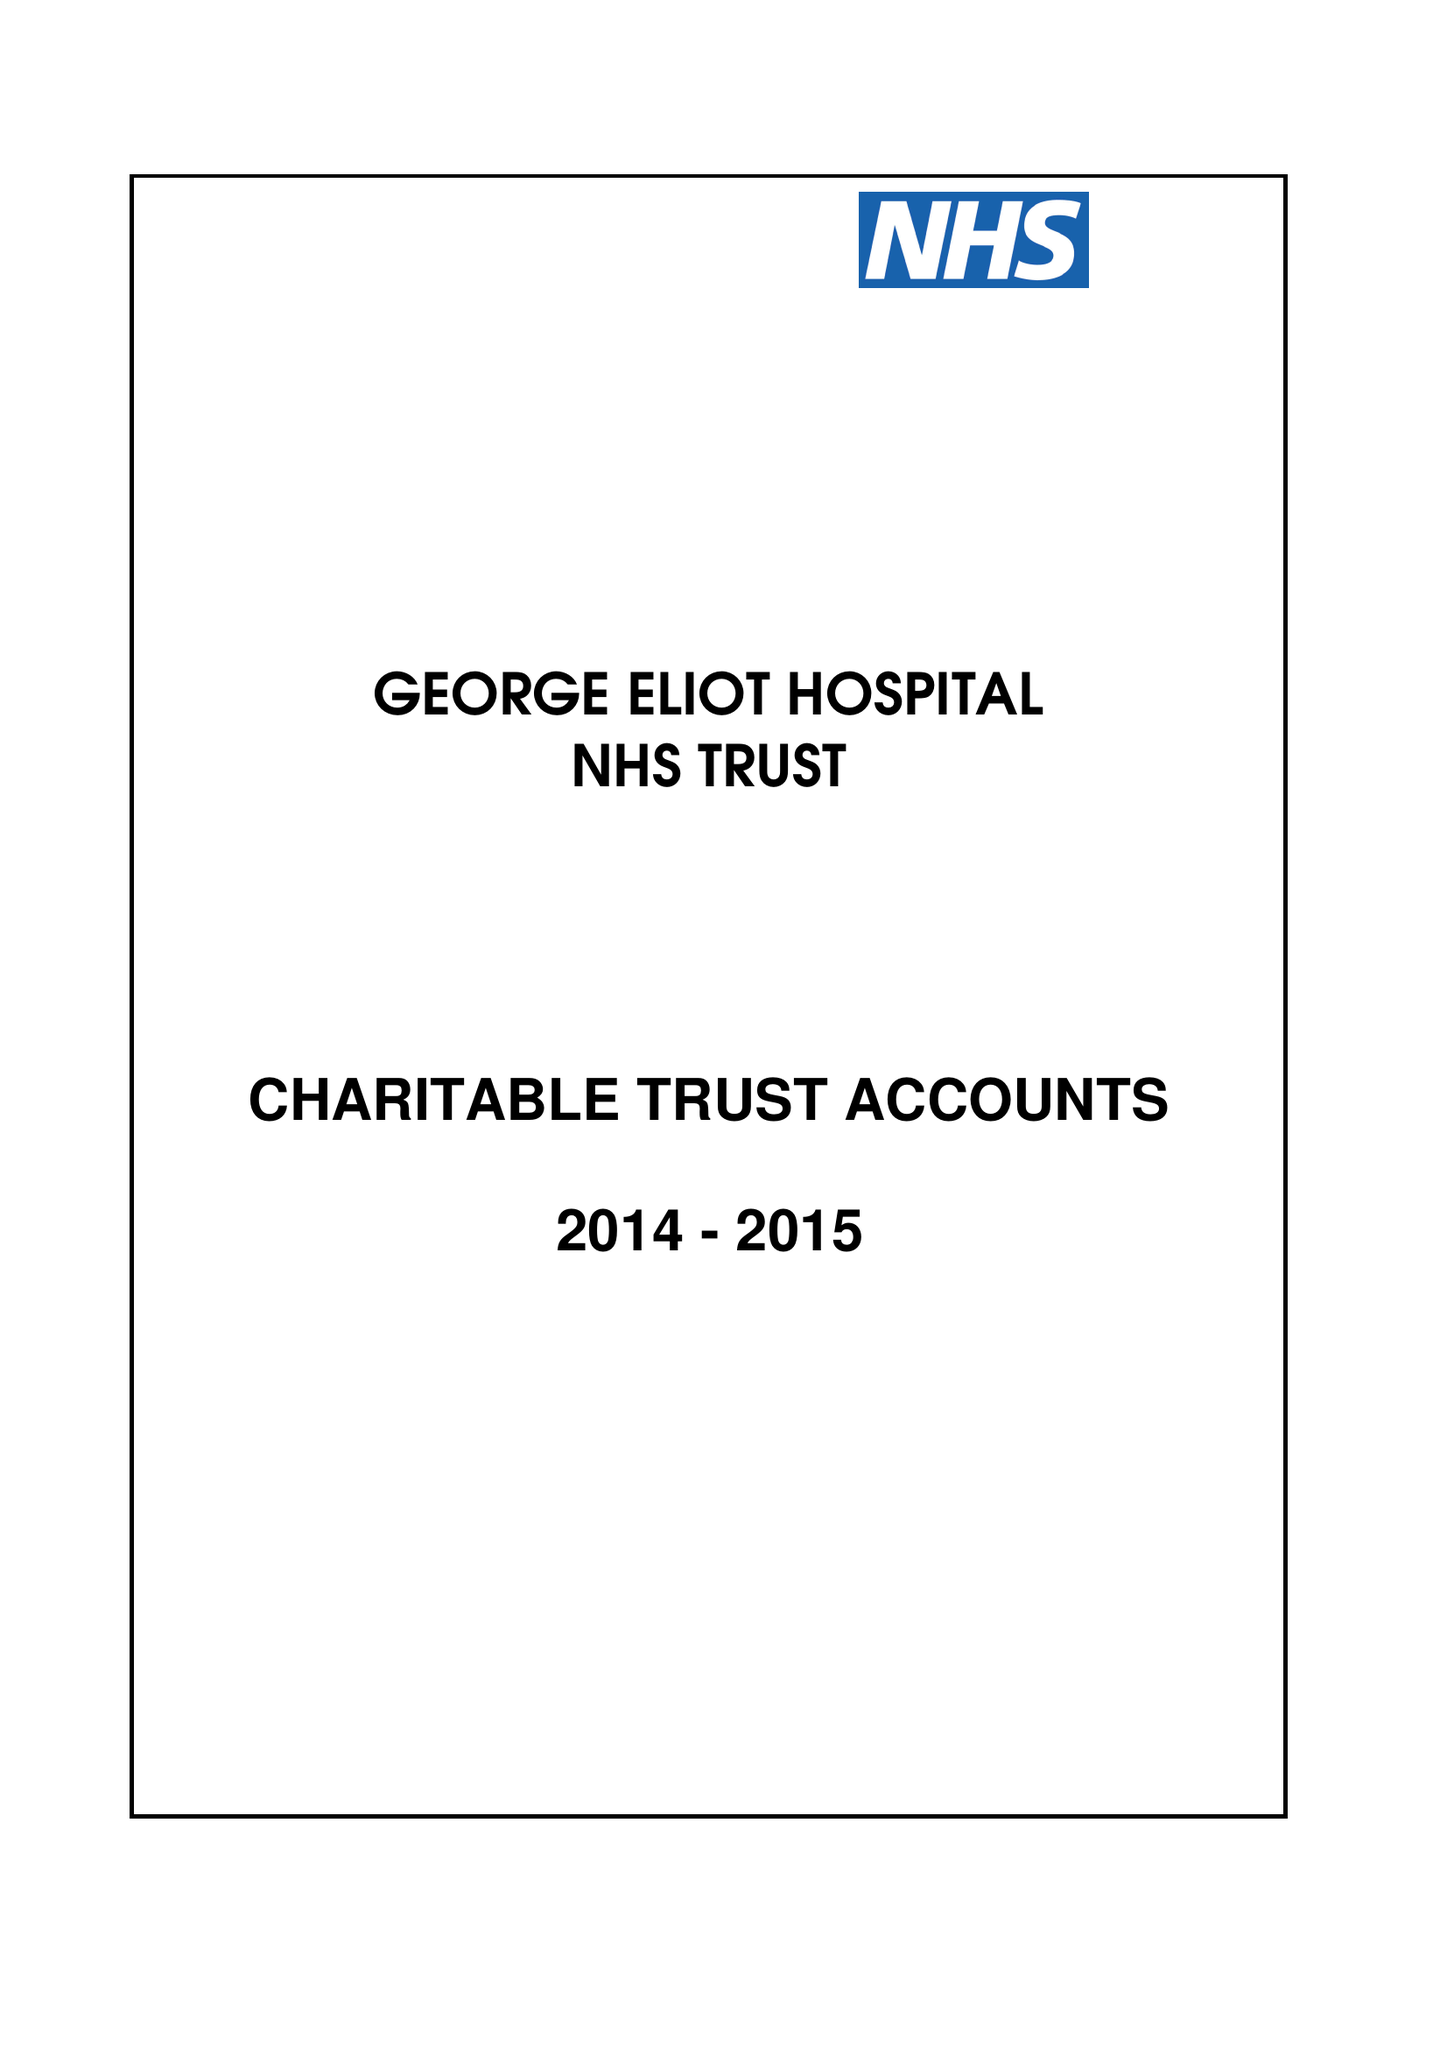What is the value for the address__street_line?
Answer the question using a single word or phrase. COLLEGE STREET 